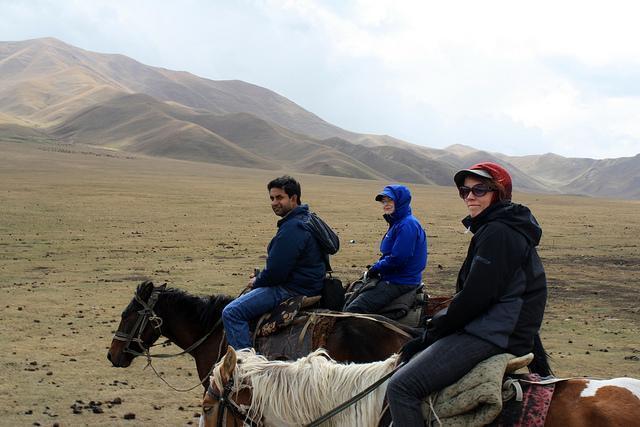What are the people turning to look at?
Choose the right answer from the provided options to respond to the question.
Options: Animal, camera, sea, traffic. Camera. 